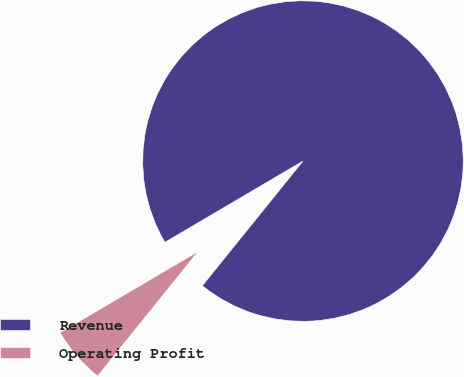Convert chart. <chart><loc_0><loc_0><loc_500><loc_500><pie_chart><fcel>Revenue<fcel>Operating Profit<nl><fcel>94.27%<fcel>5.73%<nl></chart> 